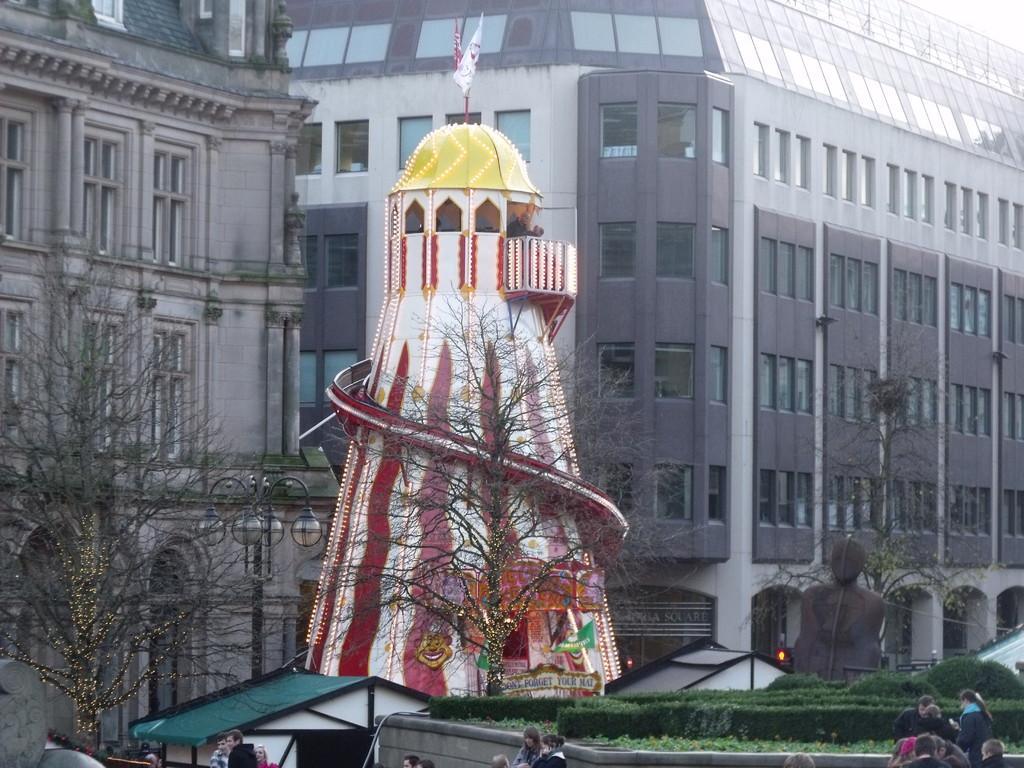In one or two sentences, can you explain what this image depicts? In this picture in the front there are persons. In the center there is grass on the ground, there are dry trees and there is a tower and there is a sculpture and on the top of the tower there is a flag. In the background there are buildings. 